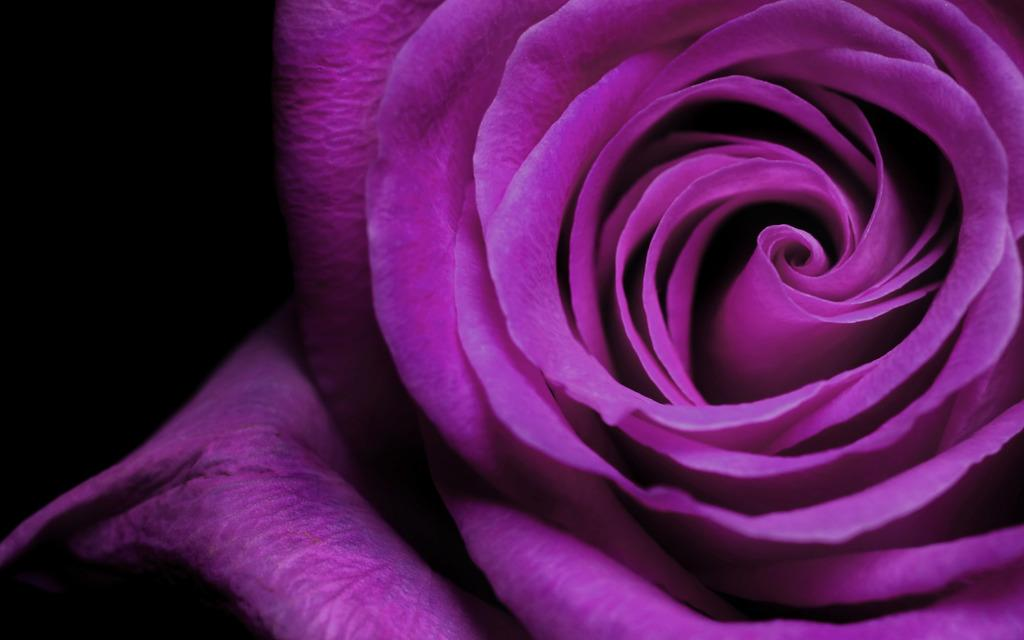What type of flower is in the image? There is a rose in the image. What color is the rose? The rose is purple in color. Can you hear the guitar being played in the image? There is no guitar present in the image, so it cannot be heard. 